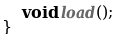<code> <loc_0><loc_0><loc_500><loc_500><_Java_>    void load();
}
</code> 